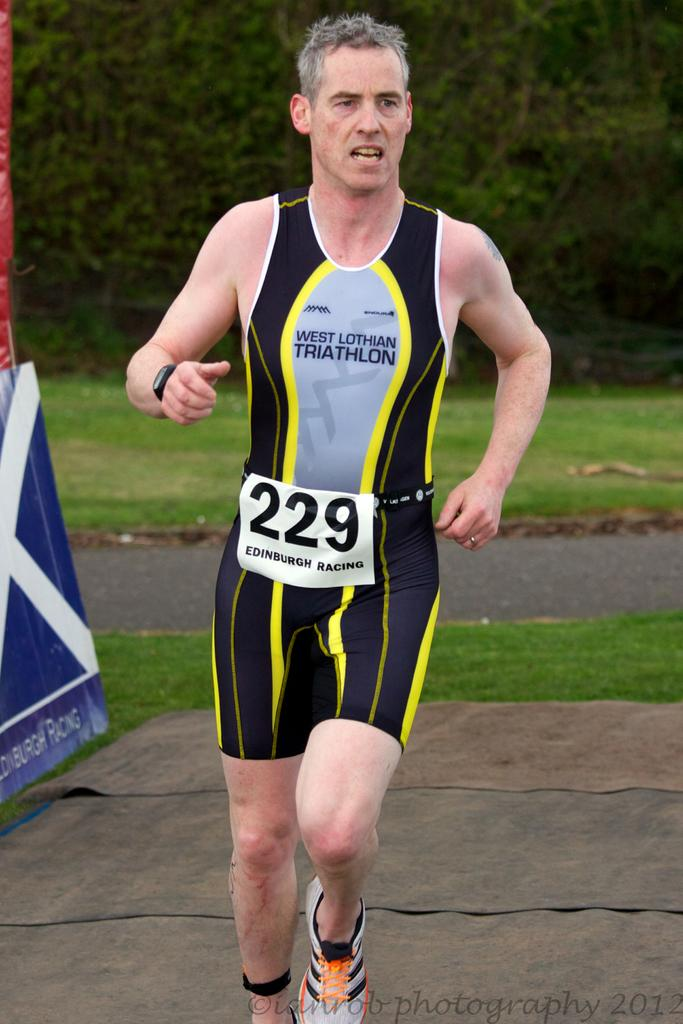<image>
Share a concise interpretation of the image provided. a man that is running with 229 on their waist 